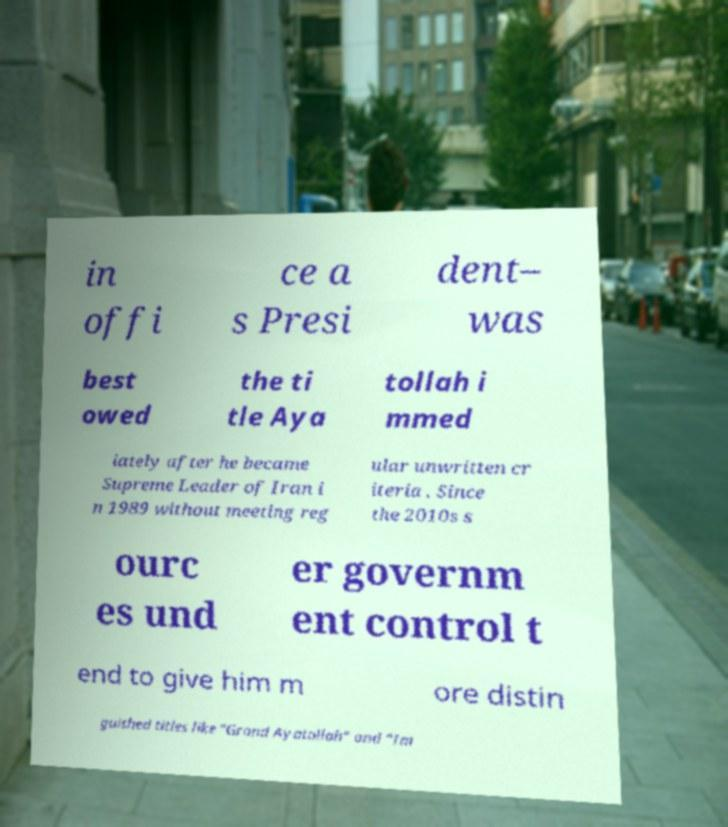Please read and relay the text visible in this image. What does it say? in offi ce a s Presi dent– was best owed the ti tle Aya tollah i mmed iately after he became Supreme Leader of Iran i n 1989 without meeting reg ular unwritten cr iteria . Since the 2010s s ourc es und er governm ent control t end to give him m ore distin guished titles like "Grand Ayatollah" and "Im 